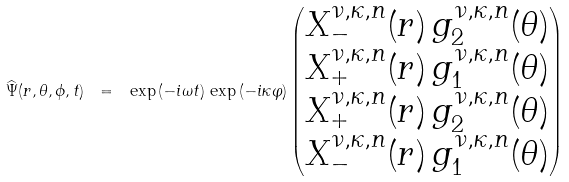Convert formula to latex. <formula><loc_0><loc_0><loc_500><loc_500>\widehat { \Psi } ( r , \theta , \phi , t ) \ = \ \exp { ( - i \omega t ) } \, \exp { ( - i \kappa \varphi ) } \begin{pmatrix} X _ { - } ^ { \nu , \kappa , n } ( r ) \, g _ { 2 } ^ { \nu , \kappa , n } ( \theta ) \\ X _ { + } ^ { \nu , \kappa , n } ( r ) \, g _ { 1 } ^ { \nu , \kappa , n } ( \theta ) \\ X _ { + } ^ { \nu , \kappa , n } ( r ) \, g _ { 2 } ^ { \nu , \kappa , n } ( \theta ) \\ X _ { - } ^ { \nu , \kappa , n } ( r ) \, g _ { 1 } ^ { \nu , \kappa , n } ( \theta ) \end{pmatrix}</formula> 